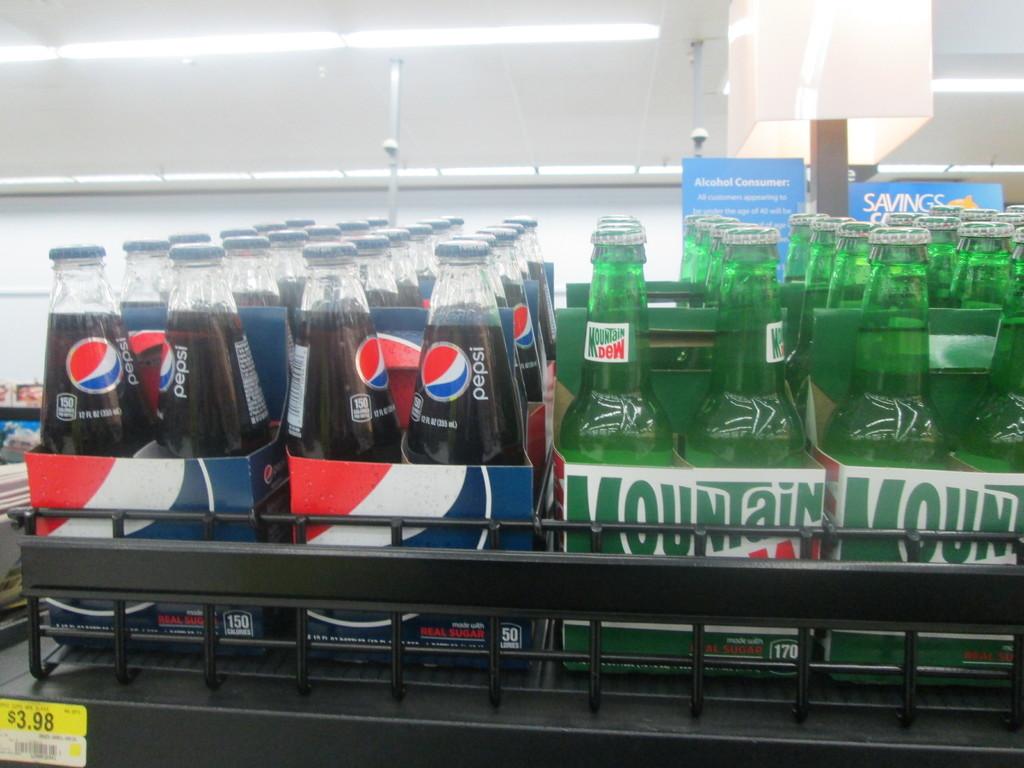What brand is the green soda?
Offer a very short reply. Mountain dew. 